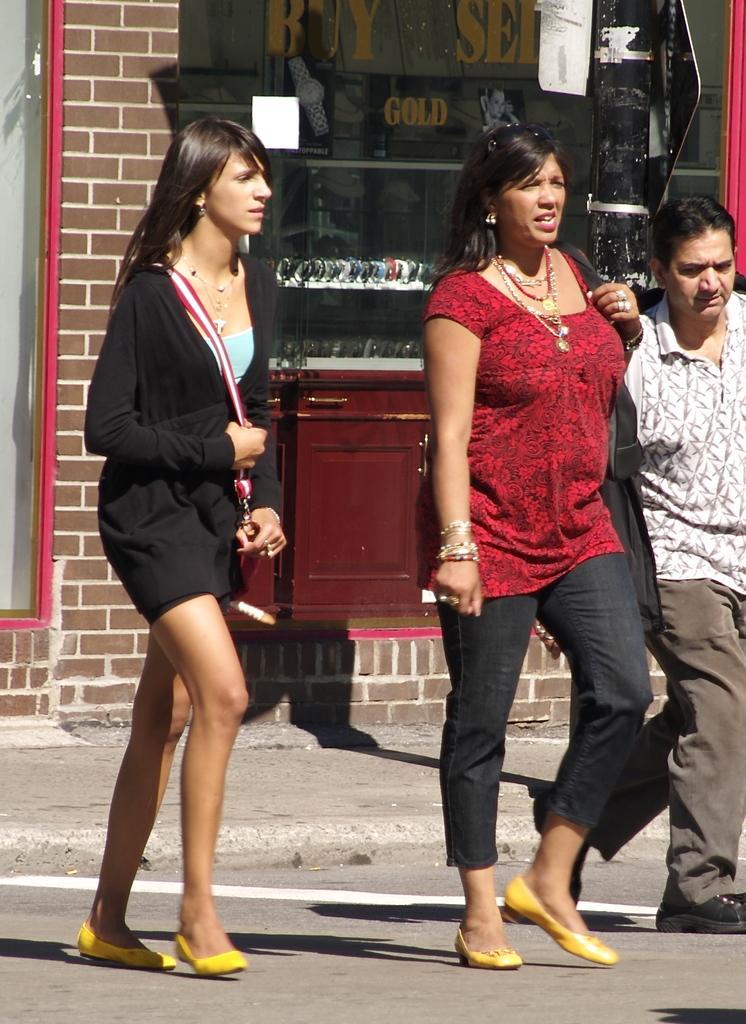Can you describe this image briefly? In this image I can see few persons walking. In front the person is wearing black color dress, background I can see the stall and the wall is in brown color. 